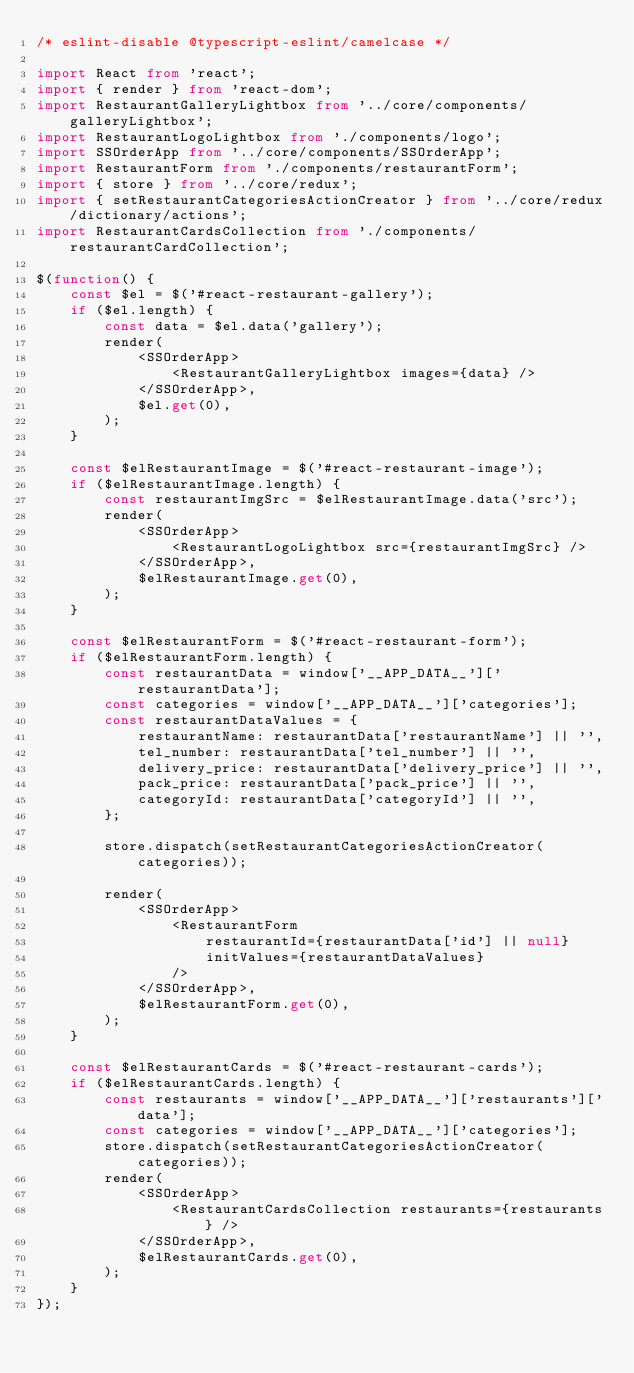<code> <loc_0><loc_0><loc_500><loc_500><_TypeScript_>/* eslint-disable @typescript-eslint/camelcase */

import React from 'react';
import { render } from 'react-dom';
import RestaurantGalleryLightbox from '../core/components/galleryLightbox';
import RestaurantLogoLightbox from './components/logo';
import SSOrderApp from '../core/components/SSOrderApp';
import RestaurantForm from './components/restaurantForm';
import { store } from '../core/redux';
import { setRestaurantCategoriesActionCreator } from '../core/redux/dictionary/actions';
import RestaurantCardsCollection from './components/restaurantCardCollection';

$(function() {
    const $el = $('#react-restaurant-gallery');
    if ($el.length) {
        const data = $el.data('gallery');
        render(
            <SSOrderApp>
                <RestaurantGalleryLightbox images={data} />
            </SSOrderApp>,
            $el.get(0),
        );
    }

    const $elRestaurantImage = $('#react-restaurant-image');
    if ($elRestaurantImage.length) {
        const restaurantImgSrc = $elRestaurantImage.data('src');
        render(
            <SSOrderApp>
                <RestaurantLogoLightbox src={restaurantImgSrc} />
            </SSOrderApp>,
            $elRestaurantImage.get(0),
        );
    }

    const $elRestaurantForm = $('#react-restaurant-form');
    if ($elRestaurantForm.length) {
        const restaurantData = window['__APP_DATA__']['restaurantData'];
        const categories = window['__APP_DATA__']['categories'];
        const restaurantDataValues = {
            restaurantName: restaurantData['restaurantName'] || '',
            tel_number: restaurantData['tel_number'] || '',
            delivery_price: restaurantData['delivery_price'] || '',
            pack_price: restaurantData['pack_price'] || '',
            categoryId: restaurantData['categoryId'] || '',
        };

        store.dispatch(setRestaurantCategoriesActionCreator(categories));

        render(
            <SSOrderApp>
                <RestaurantForm
                    restaurantId={restaurantData['id'] || null}
                    initValues={restaurantDataValues}
                />
            </SSOrderApp>,
            $elRestaurantForm.get(0),
        );
    }

    const $elRestaurantCards = $('#react-restaurant-cards');
    if ($elRestaurantCards.length) {
        const restaurants = window['__APP_DATA__']['restaurants']['data'];
        const categories = window['__APP_DATA__']['categories'];
        store.dispatch(setRestaurantCategoriesActionCreator(categories));
        render(
            <SSOrderApp>
                <RestaurantCardsCollection restaurants={restaurants} />
            </SSOrderApp>,
            $elRestaurantCards.get(0),
        );
    }
});
</code> 